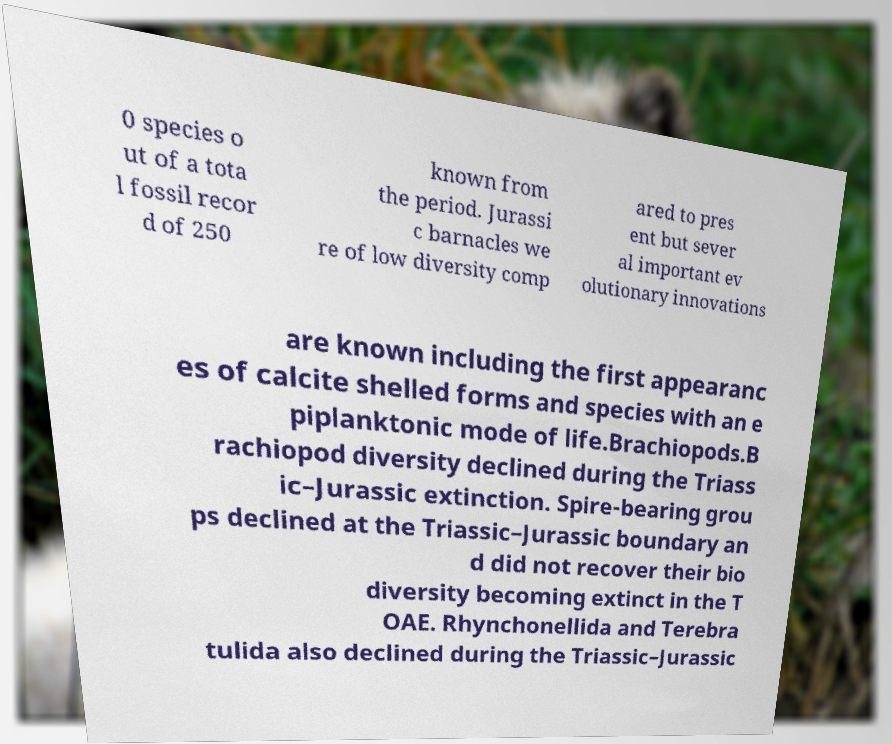Please read and relay the text visible in this image. What does it say? 0 species o ut of a tota l fossil recor d of 250 known from the period. Jurassi c barnacles we re of low diversity comp ared to pres ent but sever al important ev olutionary innovations are known including the first appearanc es of calcite shelled forms and species with an e piplanktonic mode of life.Brachiopods.B rachiopod diversity declined during the Triass ic–Jurassic extinction. Spire-bearing grou ps declined at the Triassic–Jurassic boundary an d did not recover their bio diversity becoming extinct in the T OAE. Rhynchonellida and Terebra tulida also declined during the Triassic–Jurassic 